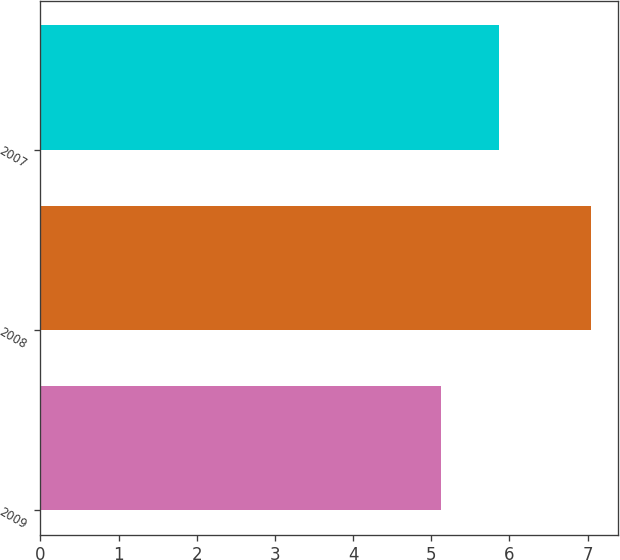Convert chart. <chart><loc_0><loc_0><loc_500><loc_500><bar_chart><fcel>2009<fcel>2008<fcel>2007<nl><fcel>5.13<fcel>7.04<fcel>5.87<nl></chart> 